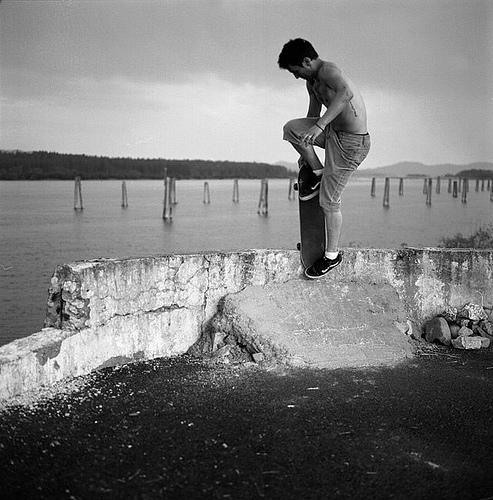Question: how many wheels of the board do you see?
Choices:
A. 9.
B. 2.
C. 8.
D. 7.
Answer with the letter. Answer: B Question: how many shoes do you see?
Choices:
A. 3.
B. 2.
C. 6.
D. 4.
Answer with the letter. Answer: B Question: what article of clothing is the person wearing?
Choices:
A. Sweater.
B. Pants.
C. Jacket.
D. Shorts.
Answer with the letter. Answer: D Question: where was the picture taken?
Choices:
A. Mountain.
B. Docks.
C. River.
D. The beach.
Answer with the letter. Answer: D Question: how many people are depicted?
Choices:
A. 5.
B. 6.
C. 1.
D. 7.
Answer with the letter. Answer: C Question: what vessels are in the background?
Choices:
A. Boats.
B. Cars.
C. Semi Trucks.
D. Jet Skis.
Answer with the letter. Answer: A 